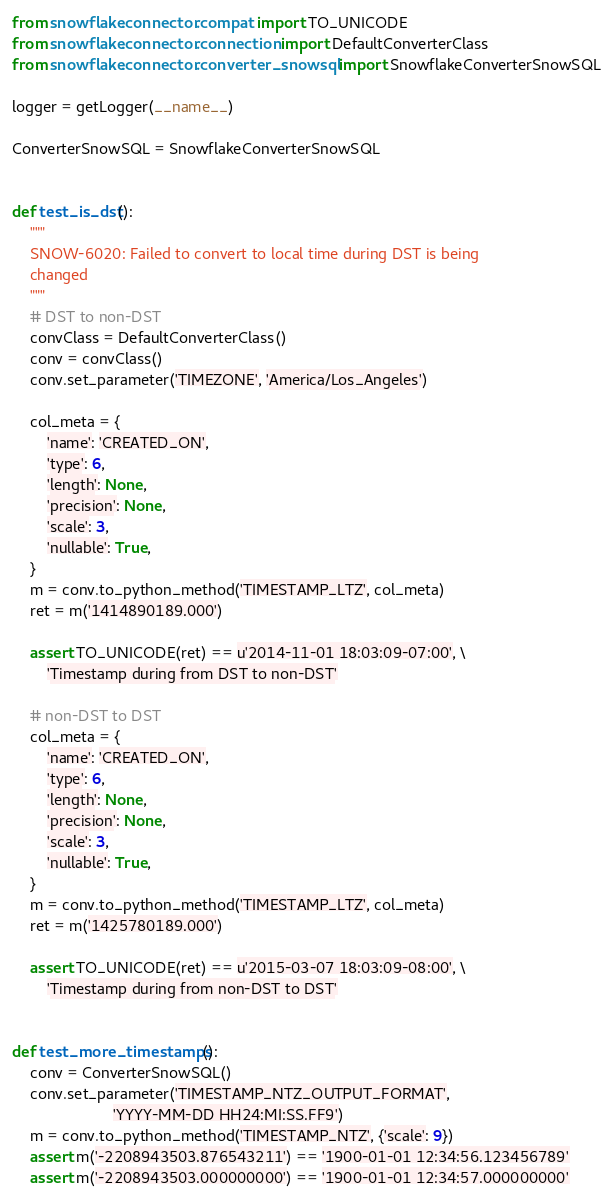<code> <loc_0><loc_0><loc_500><loc_500><_Python_>from snowflake.connector.compat import TO_UNICODE
from snowflake.connector.connection import DefaultConverterClass
from snowflake.connector.converter_snowsql import SnowflakeConverterSnowSQL

logger = getLogger(__name__)

ConverterSnowSQL = SnowflakeConverterSnowSQL


def test_is_dst():
    """
    SNOW-6020: Failed to convert to local time during DST is being
    changed
    """
    # DST to non-DST
    convClass = DefaultConverterClass()
    conv = convClass()
    conv.set_parameter('TIMEZONE', 'America/Los_Angeles')

    col_meta = {
        'name': 'CREATED_ON',
        'type': 6,
        'length': None,
        'precision': None,
        'scale': 3,
        'nullable': True,
    }
    m = conv.to_python_method('TIMESTAMP_LTZ', col_meta)
    ret = m('1414890189.000')

    assert TO_UNICODE(ret) == u'2014-11-01 18:03:09-07:00', \
        'Timestamp during from DST to non-DST'

    # non-DST to DST
    col_meta = {
        'name': 'CREATED_ON',
        'type': 6,
        'length': None,
        'precision': None,
        'scale': 3,
        'nullable': True,
    }
    m = conv.to_python_method('TIMESTAMP_LTZ', col_meta)
    ret = m('1425780189.000')

    assert TO_UNICODE(ret) == u'2015-03-07 18:03:09-08:00', \
        'Timestamp during from non-DST to DST'


def test_more_timestamps():
    conv = ConverterSnowSQL()
    conv.set_parameter('TIMESTAMP_NTZ_OUTPUT_FORMAT',
                       'YYYY-MM-DD HH24:MI:SS.FF9')
    m = conv.to_python_method('TIMESTAMP_NTZ', {'scale': 9})
    assert m('-2208943503.876543211') == '1900-01-01 12:34:56.123456789'
    assert m('-2208943503.000000000') == '1900-01-01 12:34:57.000000000'</code> 